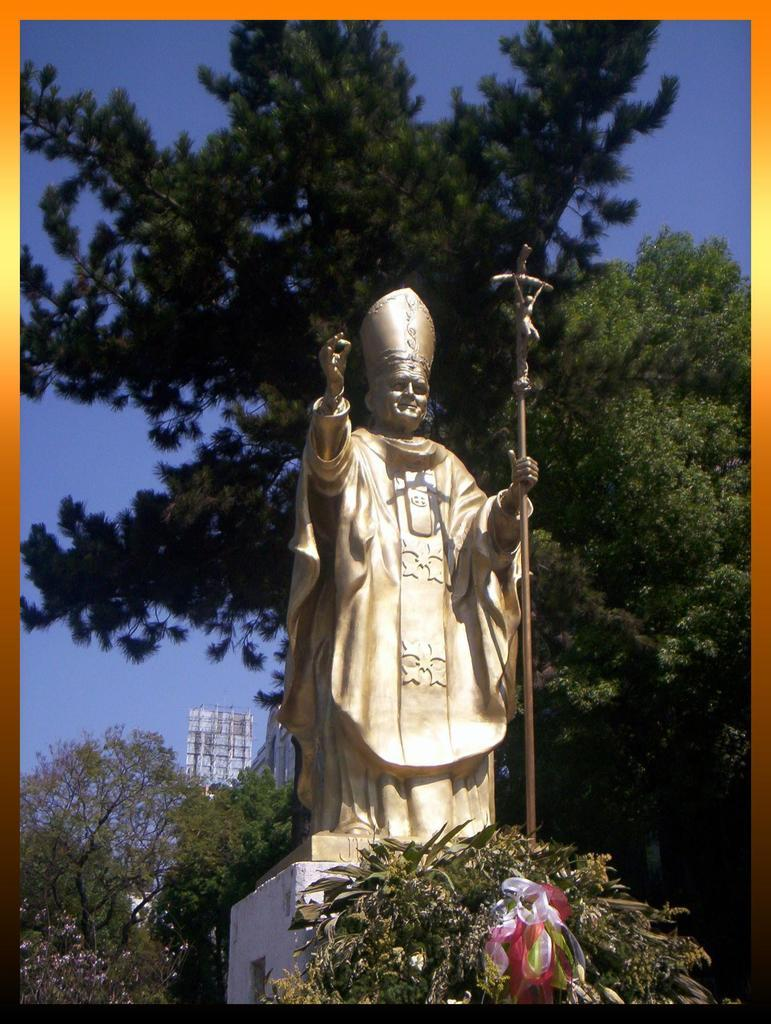What is the main subject in the image? There is a statue in the image. What is located in the front of the image? There is a plant in the front of the image. What can be seen in the background of the image? There are trees and a hoarding in the background of the image. What is visible at the top of the image? The sky is visible at the top of the image. How many servants are attending to the statue in the image? There are no servants present in the image; it only features a statue, a plant, trees, a hoarding, and the sky. What type of lizards can be seen climbing on the statue in the image? There are no lizards present in the image; it only features a statue, a plant, trees, a hoarding, and the sky. 